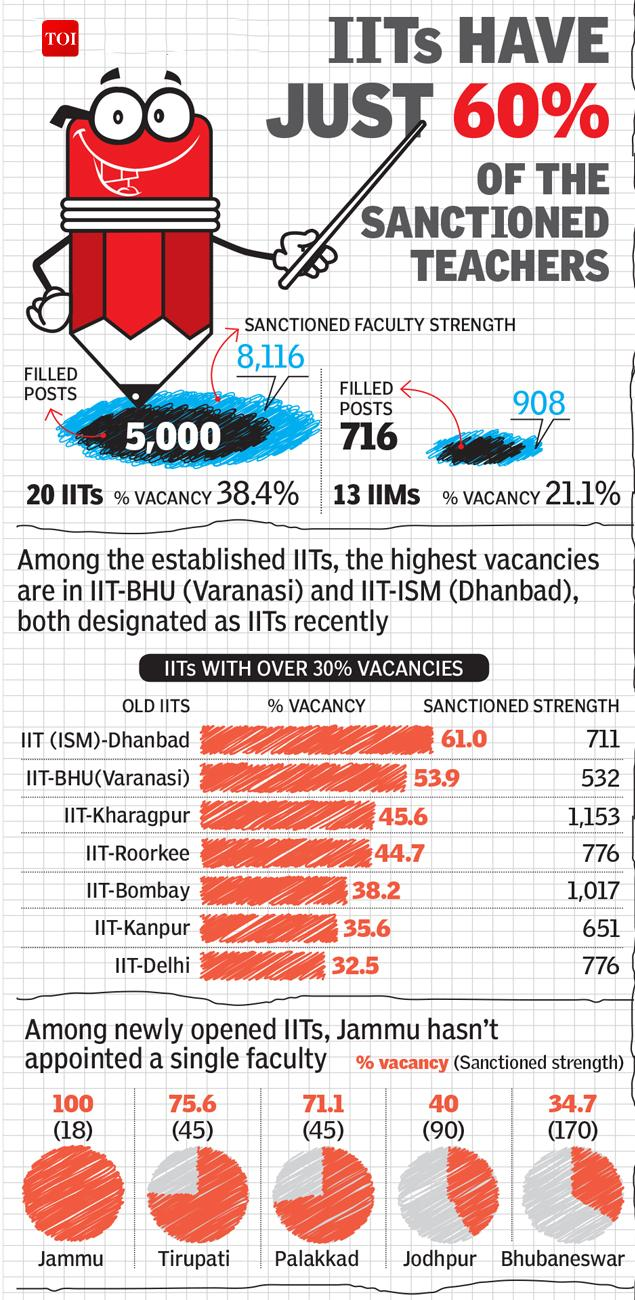Specify some key components in this picture. The sanctioned faculty strength at IIMs stands at 908. The sanctioned faculty strength at IIT-Bombay is 1,017. Approximately 5,000 faculty positions have been filled in the 20 IITs. The IIT that has a higher than 60% faculty vacancy is IIT (ISM)-Dhanbad. The faculty vacancy at IIT, Tirupati is 75.6%. 